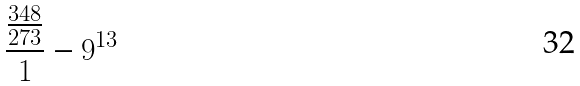<formula> <loc_0><loc_0><loc_500><loc_500>\frac { \frac { 3 4 8 } { 2 7 3 } } { 1 } - 9 ^ { 1 3 }</formula> 